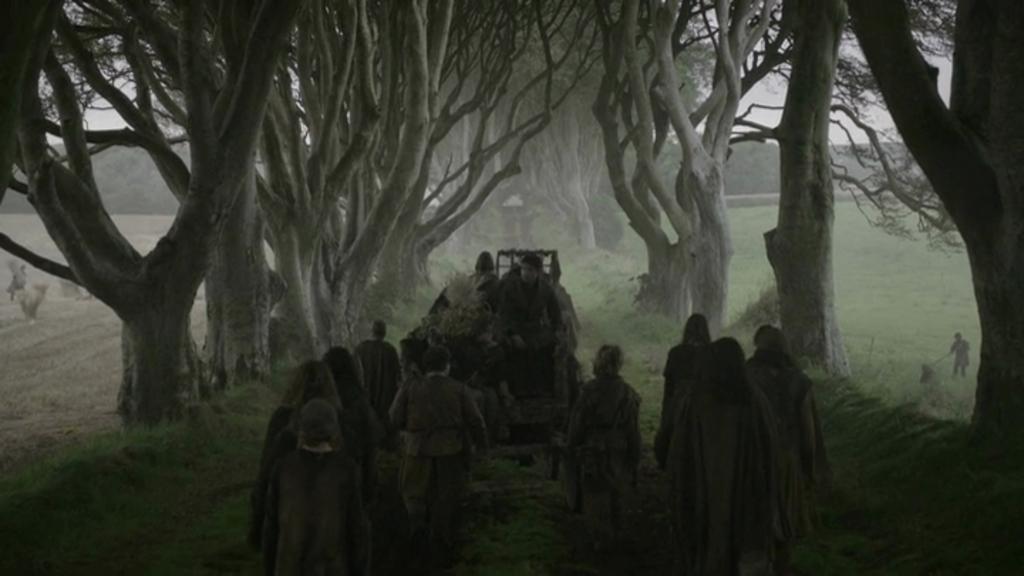Describe this image in one or two sentences. In this picture I can see group of people, there is a vehicle, there are plants, trees, and in the background there is sky. 